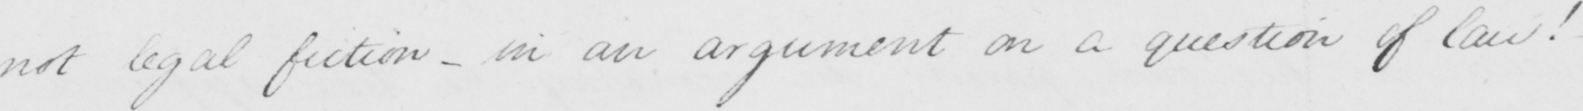Can you read and transcribe this handwriting? not legal fiction  _  in an argument on a question of law !   _ 